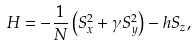<formula> <loc_0><loc_0><loc_500><loc_500>H = - \frac { 1 } { N } \left ( S _ { x } ^ { 2 } + \gamma S _ { y } ^ { 2 } \right ) - h S _ { z } ,</formula> 